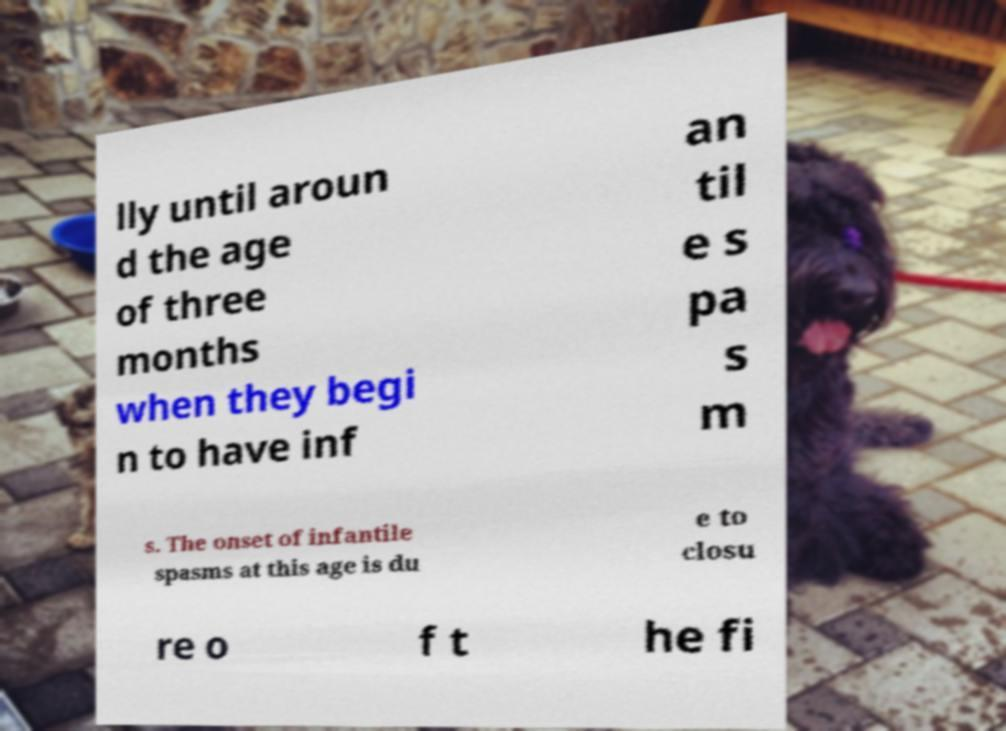What messages or text are displayed in this image? I need them in a readable, typed format. lly until aroun d the age of three months when they begi n to have inf an til e s pa s m s. The onset of infantile spasms at this age is du e to closu re o f t he fi 